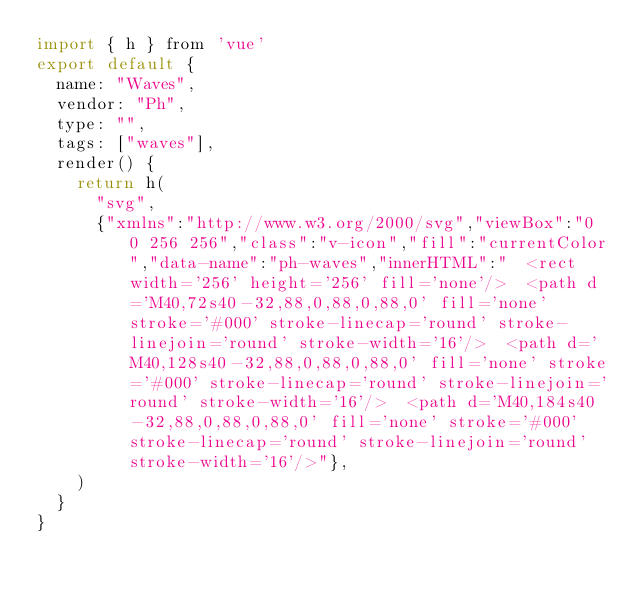Convert code to text. <code><loc_0><loc_0><loc_500><loc_500><_JavaScript_>import { h } from 'vue'
export default {
  name: "Waves",
  vendor: "Ph",
  type: "",
  tags: ["waves"],
  render() {
    return h(
      "svg",
      {"xmlns":"http://www.w3.org/2000/svg","viewBox":"0 0 256 256","class":"v-icon","fill":"currentColor","data-name":"ph-waves","innerHTML":"  <rect width='256' height='256' fill='none'/>  <path d='M40,72s40-32,88,0,88,0,88,0' fill='none' stroke='#000' stroke-linecap='round' stroke-linejoin='round' stroke-width='16'/>  <path d='M40,128s40-32,88,0,88,0,88,0' fill='none' stroke='#000' stroke-linecap='round' stroke-linejoin='round' stroke-width='16'/>  <path d='M40,184s40-32,88,0,88,0,88,0' fill='none' stroke='#000' stroke-linecap='round' stroke-linejoin='round' stroke-width='16'/>"},
    )
  }
}</code> 